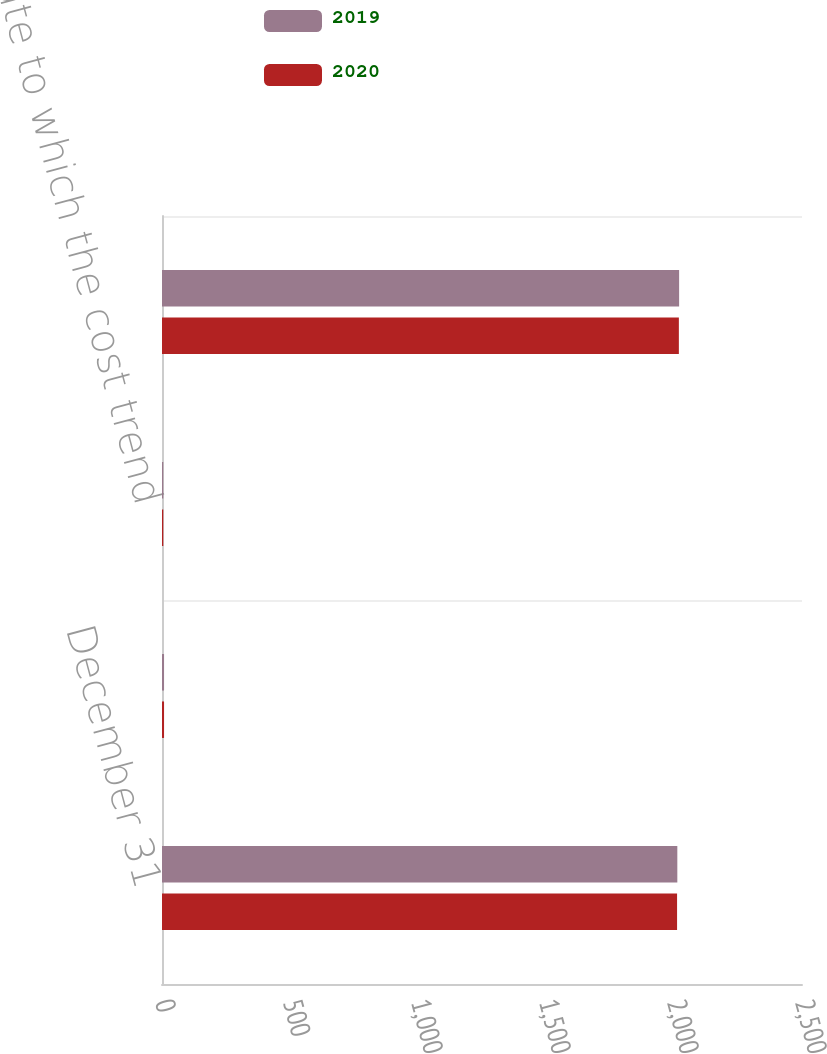<chart> <loc_0><loc_0><loc_500><loc_500><stacked_bar_chart><ecel><fcel>December 31<fcel>Health care cost trend rate<fcel>Rate to which the cost trend<fcel>Year that the rate reaches the<nl><fcel>2019<fcel>2013<fcel>8<fcel>5<fcel>2020<nl><fcel>2020<fcel>2012<fcel>8<fcel>5<fcel>2019<nl></chart> 